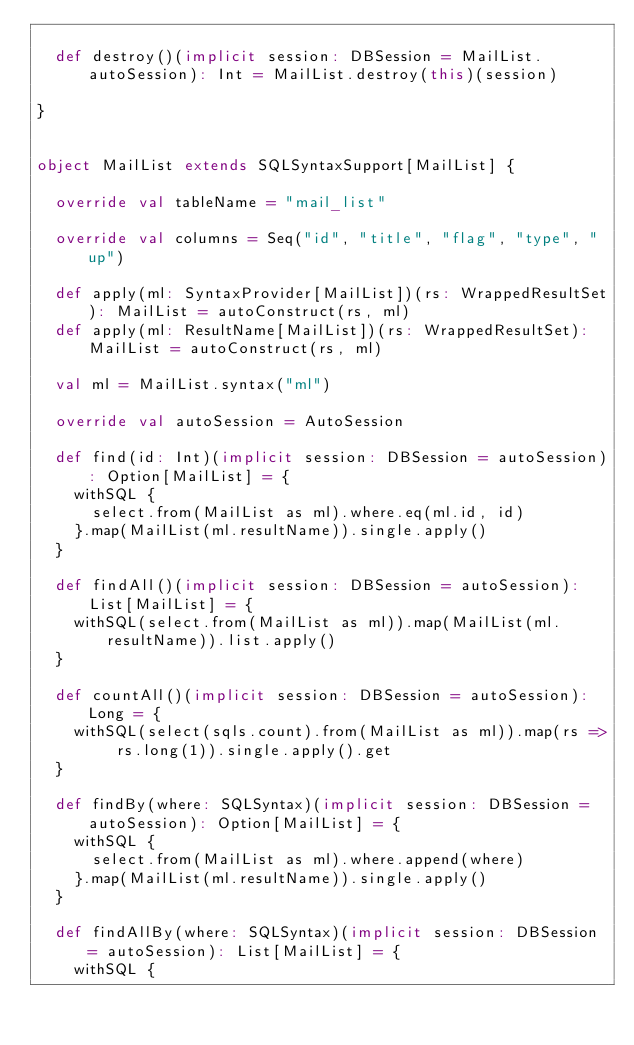Convert code to text. <code><loc_0><loc_0><loc_500><loc_500><_Scala_>
  def destroy()(implicit session: DBSession = MailList.autoSession): Int = MailList.destroy(this)(session)

}


object MailList extends SQLSyntaxSupport[MailList] {

  override val tableName = "mail_list"

  override val columns = Seq("id", "title", "flag", "type", "up")

  def apply(ml: SyntaxProvider[MailList])(rs: WrappedResultSet): MailList = autoConstruct(rs, ml)
  def apply(ml: ResultName[MailList])(rs: WrappedResultSet): MailList = autoConstruct(rs, ml)

  val ml = MailList.syntax("ml")

  override val autoSession = AutoSession

  def find(id: Int)(implicit session: DBSession = autoSession): Option[MailList] = {
    withSQL {
      select.from(MailList as ml).where.eq(ml.id, id)
    }.map(MailList(ml.resultName)).single.apply()
  }

  def findAll()(implicit session: DBSession = autoSession): List[MailList] = {
    withSQL(select.from(MailList as ml)).map(MailList(ml.resultName)).list.apply()
  }

  def countAll()(implicit session: DBSession = autoSession): Long = {
    withSQL(select(sqls.count).from(MailList as ml)).map(rs => rs.long(1)).single.apply().get
  }

  def findBy(where: SQLSyntax)(implicit session: DBSession = autoSession): Option[MailList] = {
    withSQL {
      select.from(MailList as ml).where.append(where)
    }.map(MailList(ml.resultName)).single.apply()
  }

  def findAllBy(where: SQLSyntax)(implicit session: DBSession = autoSession): List[MailList] = {
    withSQL {</code> 